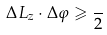<formula> <loc_0><loc_0><loc_500><loc_500>\Delta L _ { z } \cdot \Delta \varphi \geqslant \frac { } { 2 }</formula> 